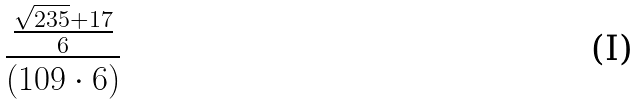<formula> <loc_0><loc_0><loc_500><loc_500>\frac { \frac { \sqrt { 2 3 5 } + 1 7 } { 6 } } { ( 1 0 9 \cdot 6 ) }</formula> 